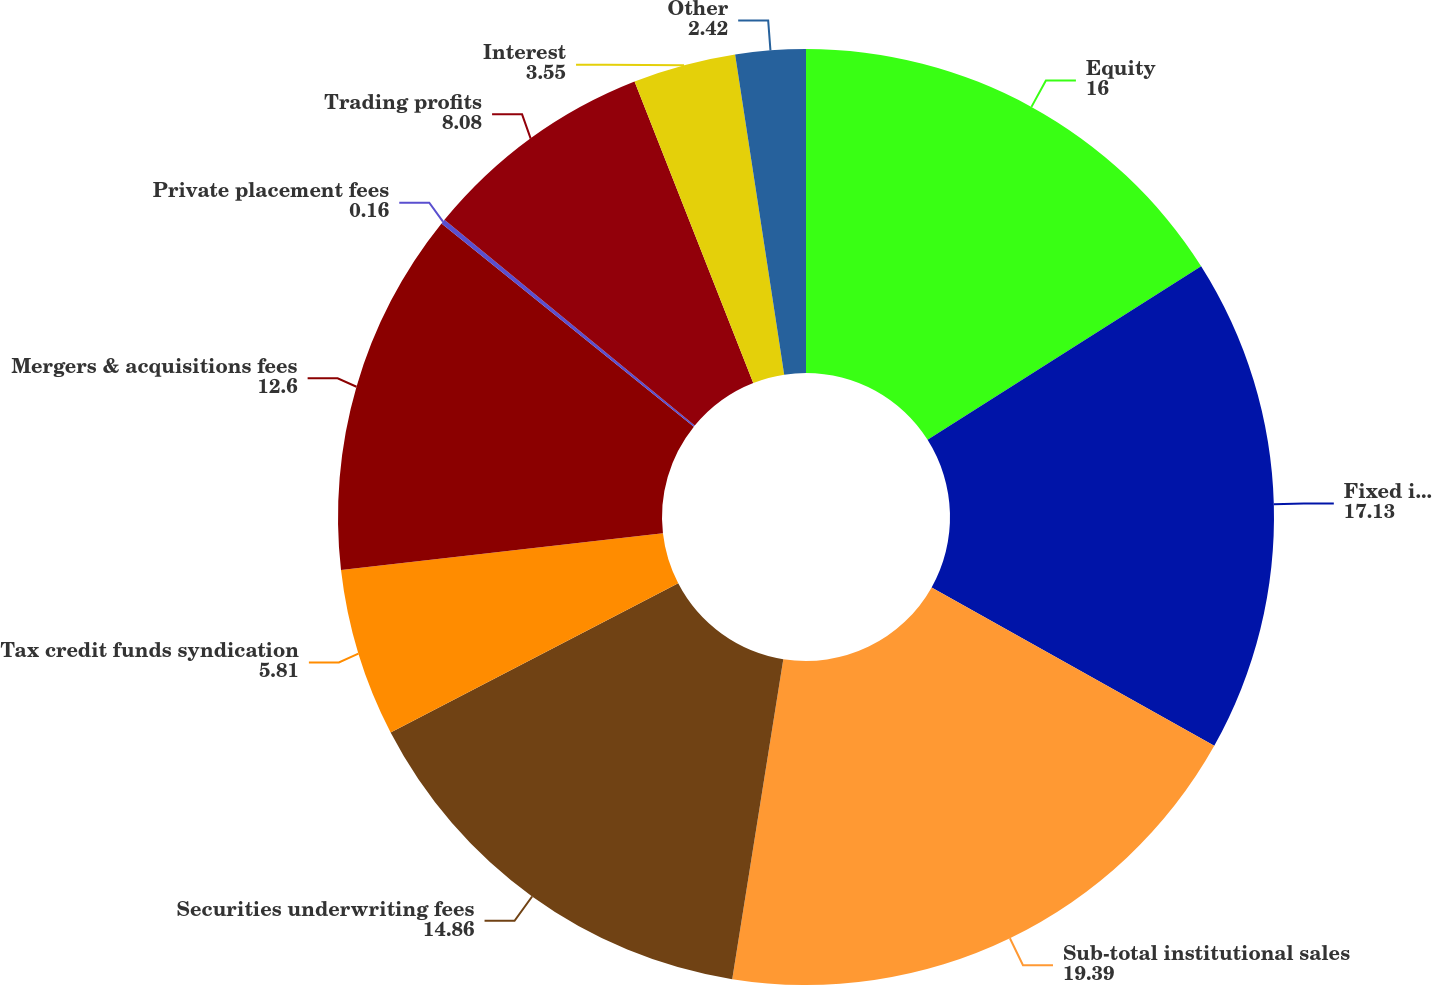Convert chart. <chart><loc_0><loc_0><loc_500><loc_500><pie_chart><fcel>Equity<fcel>Fixed income<fcel>Sub-total institutional sales<fcel>Securities underwriting fees<fcel>Tax credit funds syndication<fcel>Mergers & acquisitions fees<fcel>Private placement fees<fcel>Trading profits<fcel>Interest<fcel>Other<nl><fcel>16.0%<fcel>17.13%<fcel>19.39%<fcel>14.86%<fcel>5.81%<fcel>12.6%<fcel>0.16%<fcel>8.08%<fcel>3.55%<fcel>2.42%<nl></chart> 